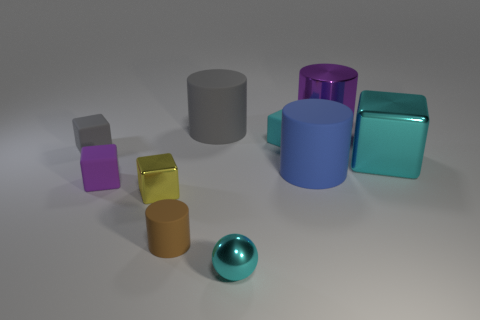Subtract 2 blocks. How many blocks are left? 3 Subtract all cyan matte blocks. How many blocks are left? 4 Subtract all gray cubes. How many cubes are left? 4 Subtract all brown blocks. Subtract all purple spheres. How many blocks are left? 5 Subtract all spheres. How many objects are left? 9 Subtract 1 gray cylinders. How many objects are left? 9 Subtract all small cyan spheres. Subtract all yellow things. How many objects are left? 8 Add 2 purple blocks. How many purple blocks are left? 3 Add 6 tiny red rubber things. How many tiny red rubber things exist? 6 